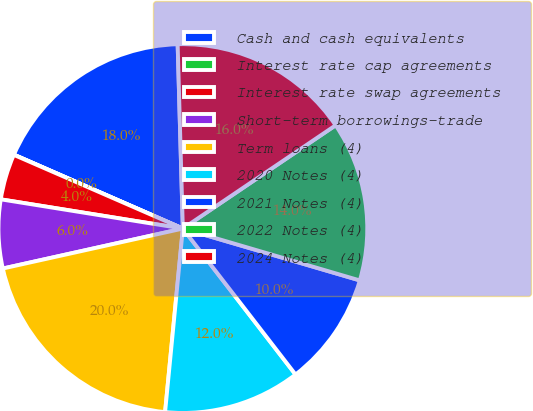<chart> <loc_0><loc_0><loc_500><loc_500><pie_chart><fcel>Cash and cash equivalents<fcel>Interest rate cap agreements<fcel>Interest rate swap agreements<fcel>Short-term borrowings-trade<fcel>Term loans (4)<fcel>2020 Notes (4)<fcel>2021 Notes (4)<fcel>2022 Notes (4)<fcel>2024 Notes (4)<nl><fcel>17.99%<fcel>0.02%<fcel>4.01%<fcel>6.01%<fcel>19.99%<fcel>12.0%<fcel>10.0%<fcel>14.0%<fcel>15.99%<nl></chart> 